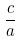Convert formula to latex. <formula><loc_0><loc_0><loc_500><loc_500>\frac { c } { a }</formula> 